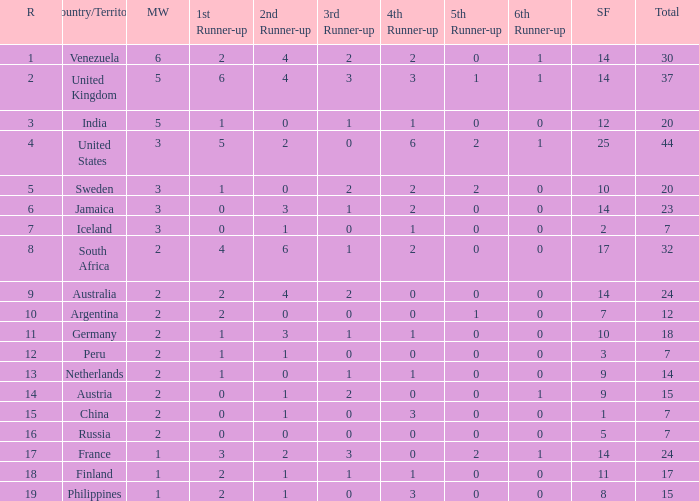In which nations does the 5th runner-up hold a ranking of 2 and the 3rd runner-up a ranking of 0? 44.0. Help me parse the entirety of this table. {'header': ['R', 'Country/Territory', 'MW', '1st Runner-up', '2nd Runner-up', '3rd Runner-up', '4th Runner-up', '5th Runner-up', '6th Runner-up', 'SF', 'Total'], 'rows': [['1', 'Venezuela', '6', '2', '4', '2', '2', '0', '1', '14', '30'], ['2', 'United Kingdom', '5', '6', '4', '3', '3', '1', '1', '14', '37'], ['3', 'India', '5', '1', '0', '1', '1', '0', '0', '12', '20'], ['4', 'United States', '3', '5', '2', '0', '6', '2', '1', '25', '44'], ['5', 'Sweden', '3', '1', '0', '2', '2', '2', '0', '10', '20'], ['6', 'Jamaica', '3', '0', '3', '1', '2', '0', '0', '14', '23'], ['7', 'Iceland', '3', '0', '1', '0', '1', '0', '0', '2', '7'], ['8', 'South Africa', '2', '4', '6', '1', '2', '0', '0', '17', '32'], ['9', 'Australia', '2', '2', '4', '2', '0', '0', '0', '14', '24'], ['10', 'Argentina', '2', '2', '0', '0', '0', '1', '0', '7', '12'], ['11', 'Germany', '2', '1', '3', '1', '1', '0', '0', '10', '18'], ['12', 'Peru', '2', '1', '1', '0', '0', '0', '0', '3', '7'], ['13', 'Netherlands', '2', '1', '0', '1', '1', '0', '0', '9', '14'], ['14', 'Austria', '2', '0', '1', '2', '0', '0', '1', '9', '15'], ['15', 'China', '2', '0', '1', '0', '3', '0', '0', '1', '7'], ['16', 'Russia', '2', '0', '0', '0', '0', '0', '0', '5', '7'], ['17', 'France', '1', '3', '2', '3', '0', '2', '1', '14', '24'], ['18', 'Finland', '1', '2', '1', '1', '1', '0', '0', '11', '17'], ['19', 'Philippines', '1', '2', '1', '0', '3', '0', '0', '8', '15']]} 